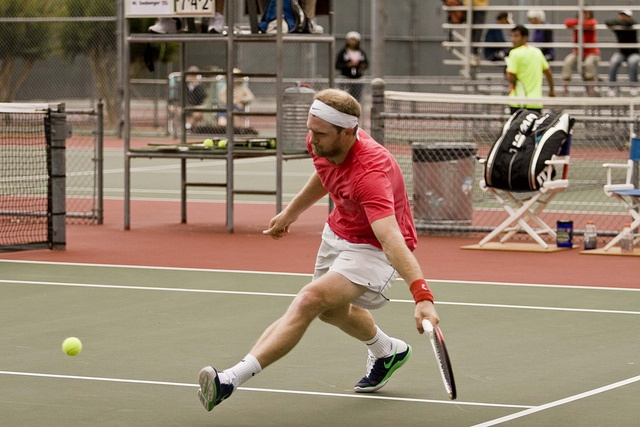Describe the objects in this image and their specific colors. I can see people in olive, darkgray, gray, and tan tones, people in olive, darkgray, gray, and tan tones, backpack in olive, black, lightgray, gray, and darkgray tones, chair in olive, tan, lightgray, and gray tones, and people in olive, khaki, and gray tones in this image. 